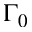<formula> <loc_0><loc_0><loc_500><loc_500>\Gamma _ { 0 }</formula> 